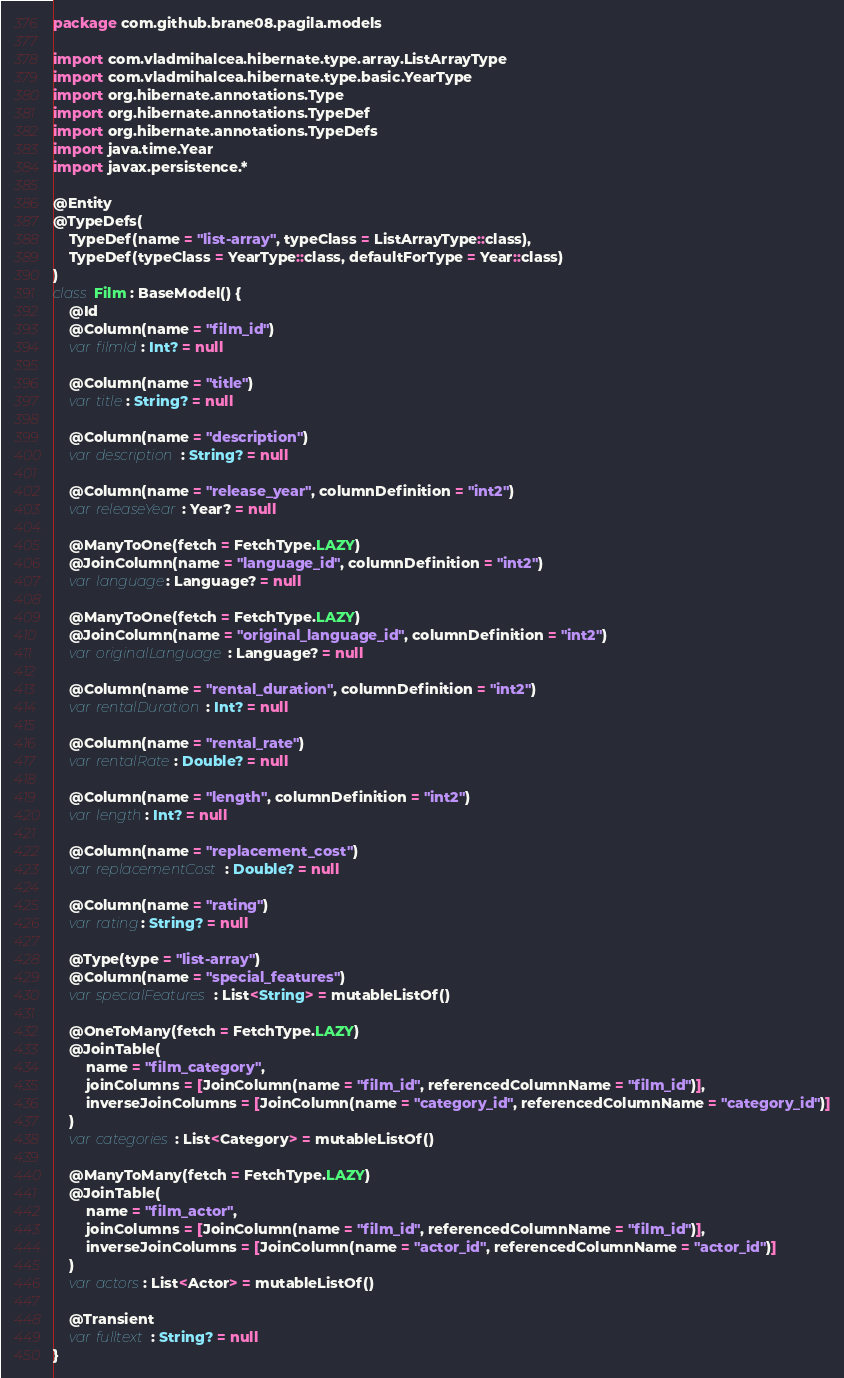<code> <loc_0><loc_0><loc_500><loc_500><_Kotlin_>package com.github.brane08.pagila.models

import com.vladmihalcea.hibernate.type.array.ListArrayType
import com.vladmihalcea.hibernate.type.basic.YearType
import org.hibernate.annotations.Type
import org.hibernate.annotations.TypeDef
import org.hibernate.annotations.TypeDefs
import java.time.Year
import javax.persistence.*

@Entity
@TypeDefs(
	TypeDef(name = "list-array", typeClass = ListArrayType::class),
	TypeDef(typeClass = YearType::class, defaultForType = Year::class)
)
class Film : BaseModel() {
	@Id
	@Column(name = "film_id")
	var filmId: Int? = null

	@Column(name = "title")
	var title: String? = null

	@Column(name = "description")
	var description: String? = null

	@Column(name = "release_year", columnDefinition = "int2")
	var releaseYear: Year? = null

	@ManyToOne(fetch = FetchType.LAZY)
	@JoinColumn(name = "language_id", columnDefinition = "int2")
	var language: Language? = null

	@ManyToOne(fetch = FetchType.LAZY)
	@JoinColumn(name = "original_language_id", columnDefinition = "int2")
	var originalLanguage: Language? = null

	@Column(name = "rental_duration", columnDefinition = "int2")
	var rentalDuration: Int? = null

	@Column(name = "rental_rate")
	var rentalRate: Double? = null

	@Column(name = "length", columnDefinition = "int2")
	var length: Int? = null

	@Column(name = "replacement_cost")
	var replacementCost: Double? = null

	@Column(name = "rating")
	var rating: String? = null

	@Type(type = "list-array")
	@Column(name = "special_features")
	var specialFeatures: List<String> = mutableListOf()

	@OneToMany(fetch = FetchType.LAZY)
	@JoinTable(
		name = "film_category",
		joinColumns = [JoinColumn(name = "film_id", referencedColumnName = "film_id")],
		inverseJoinColumns = [JoinColumn(name = "category_id", referencedColumnName = "category_id")]
	)
	var categories: List<Category> = mutableListOf()

	@ManyToMany(fetch = FetchType.LAZY)
	@JoinTable(
		name = "film_actor",
		joinColumns = [JoinColumn(name = "film_id", referencedColumnName = "film_id")],
		inverseJoinColumns = [JoinColumn(name = "actor_id", referencedColumnName = "actor_id")]
	)
	var actors: List<Actor> = mutableListOf()

	@Transient
	var fulltext: String? = null
}</code> 